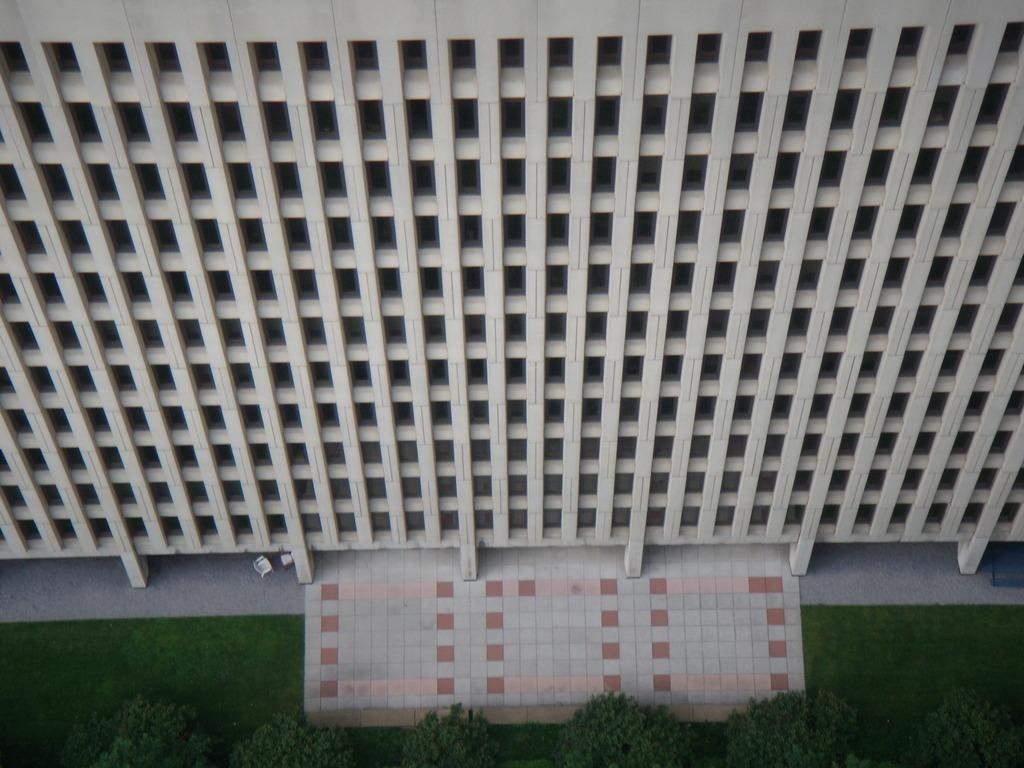What type of structure is visible in the image? There is a building in the image. What can be seen at the bottom of the image? Plants and grassy land are visible at the bottom of the image. Can you describe the vegetation present at the bottom of the image? The plants are present at the bottom of the image, and there is grassy land visible as well. What type of yarn is being used in the class depicted in the image? There is no class or yarn present in the image. 